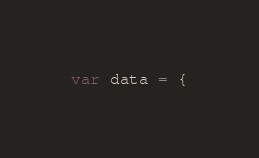Convert code to text. <code><loc_0><loc_0><loc_500><loc_500><_JavaScript_>var data = {</code> 